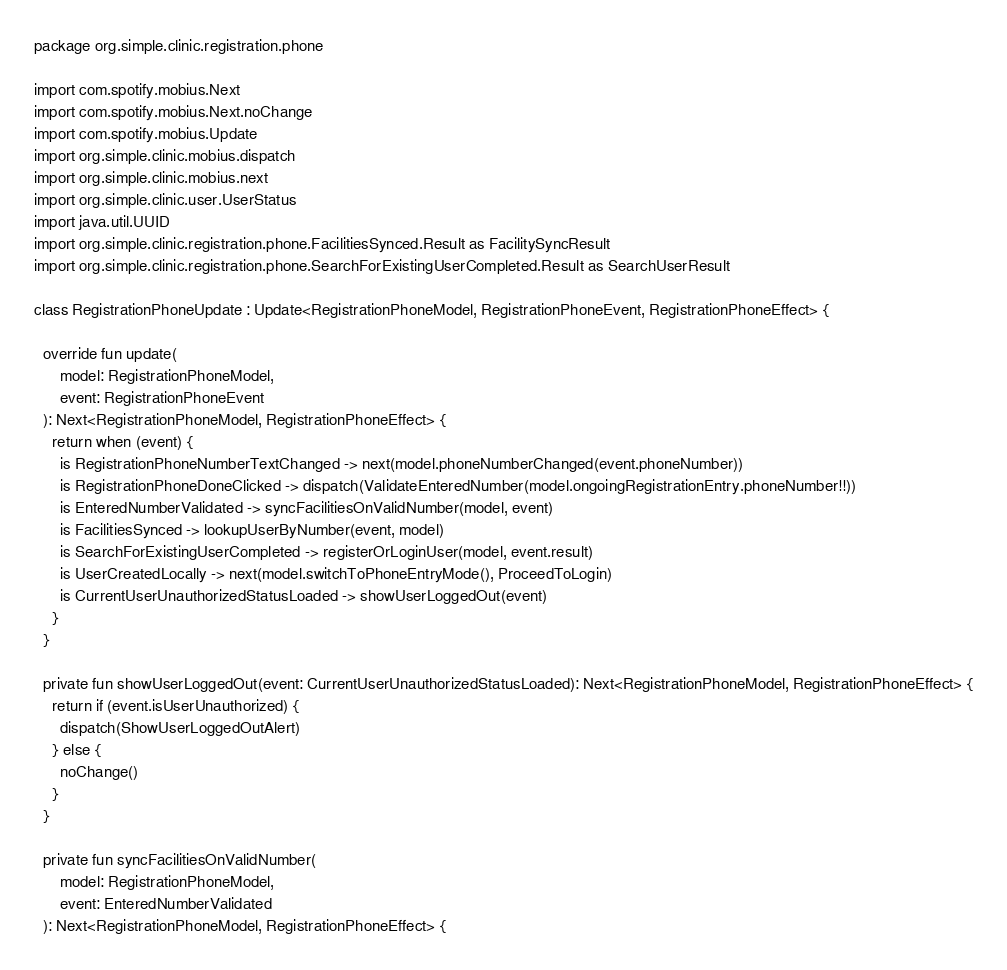<code> <loc_0><loc_0><loc_500><loc_500><_Kotlin_>package org.simple.clinic.registration.phone

import com.spotify.mobius.Next
import com.spotify.mobius.Next.noChange
import com.spotify.mobius.Update
import org.simple.clinic.mobius.dispatch
import org.simple.clinic.mobius.next
import org.simple.clinic.user.UserStatus
import java.util.UUID
import org.simple.clinic.registration.phone.FacilitiesSynced.Result as FacilitySyncResult
import org.simple.clinic.registration.phone.SearchForExistingUserCompleted.Result as SearchUserResult

class RegistrationPhoneUpdate : Update<RegistrationPhoneModel, RegistrationPhoneEvent, RegistrationPhoneEffect> {

  override fun update(
      model: RegistrationPhoneModel,
      event: RegistrationPhoneEvent
  ): Next<RegistrationPhoneModel, RegistrationPhoneEffect> {
    return when (event) {
      is RegistrationPhoneNumberTextChanged -> next(model.phoneNumberChanged(event.phoneNumber))
      is RegistrationPhoneDoneClicked -> dispatch(ValidateEnteredNumber(model.ongoingRegistrationEntry.phoneNumber!!))
      is EnteredNumberValidated -> syncFacilitiesOnValidNumber(model, event)
      is FacilitiesSynced -> lookupUserByNumber(event, model)
      is SearchForExistingUserCompleted -> registerOrLoginUser(model, event.result)
      is UserCreatedLocally -> next(model.switchToPhoneEntryMode(), ProceedToLogin)
      is CurrentUserUnauthorizedStatusLoaded -> showUserLoggedOut(event)
    }
  }

  private fun showUserLoggedOut(event: CurrentUserUnauthorizedStatusLoaded): Next<RegistrationPhoneModel, RegistrationPhoneEffect> {
    return if (event.isUserUnauthorized) {
      dispatch(ShowUserLoggedOutAlert)
    } else {
      noChange()
    }
  }

  private fun syncFacilitiesOnValidNumber(
      model: RegistrationPhoneModel,
      event: EnteredNumberValidated
  ): Next<RegistrationPhoneModel, RegistrationPhoneEffect> {</code> 